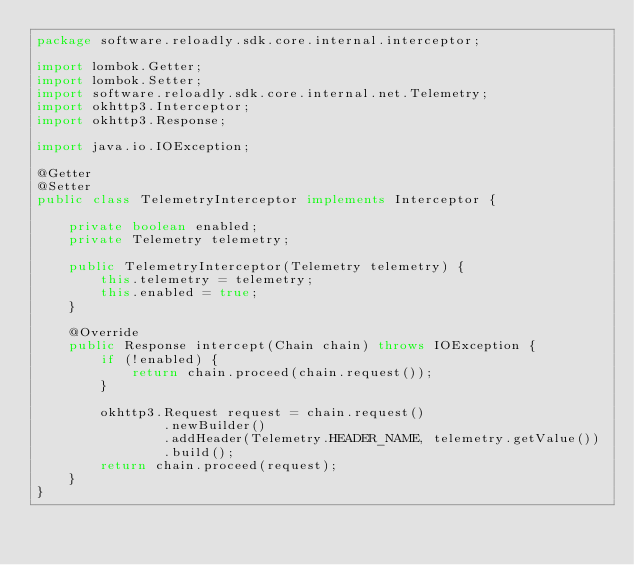Convert code to text. <code><loc_0><loc_0><loc_500><loc_500><_Java_>package software.reloadly.sdk.core.internal.interceptor;

import lombok.Getter;
import lombok.Setter;
import software.reloadly.sdk.core.internal.net.Telemetry;
import okhttp3.Interceptor;
import okhttp3.Response;

import java.io.IOException;

@Getter
@Setter
public class TelemetryInterceptor implements Interceptor {

    private boolean enabled;
    private Telemetry telemetry;

    public TelemetryInterceptor(Telemetry telemetry) {
        this.telemetry = telemetry;
        this.enabled = true;
    }

    @Override
    public Response intercept(Chain chain) throws IOException {
        if (!enabled) {
            return chain.proceed(chain.request());
        }

        okhttp3.Request request = chain.request()
                .newBuilder()
                .addHeader(Telemetry.HEADER_NAME, telemetry.getValue())
                .build();
        return chain.proceed(request);
    }
}

</code> 